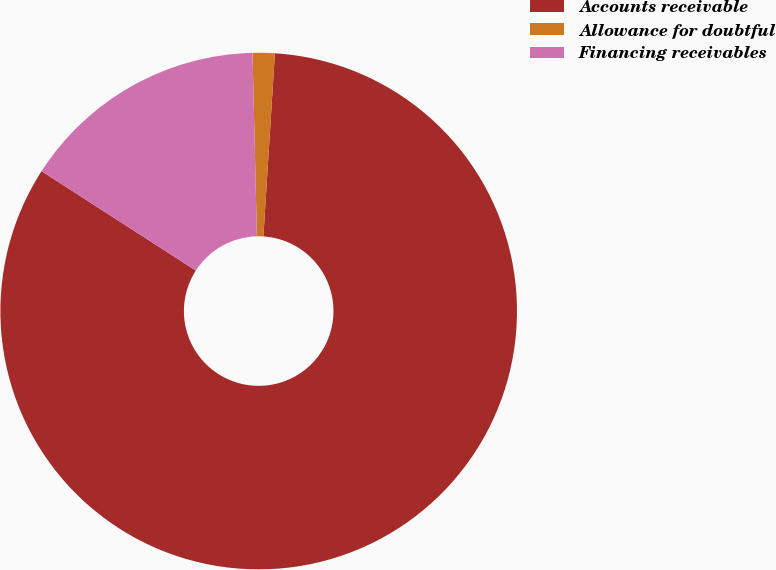Convert chart to OTSL. <chart><loc_0><loc_0><loc_500><loc_500><pie_chart><fcel>Accounts receivable<fcel>Allowance for doubtful<fcel>Financing receivables<nl><fcel>83.11%<fcel>1.38%<fcel>15.51%<nl></chart> 